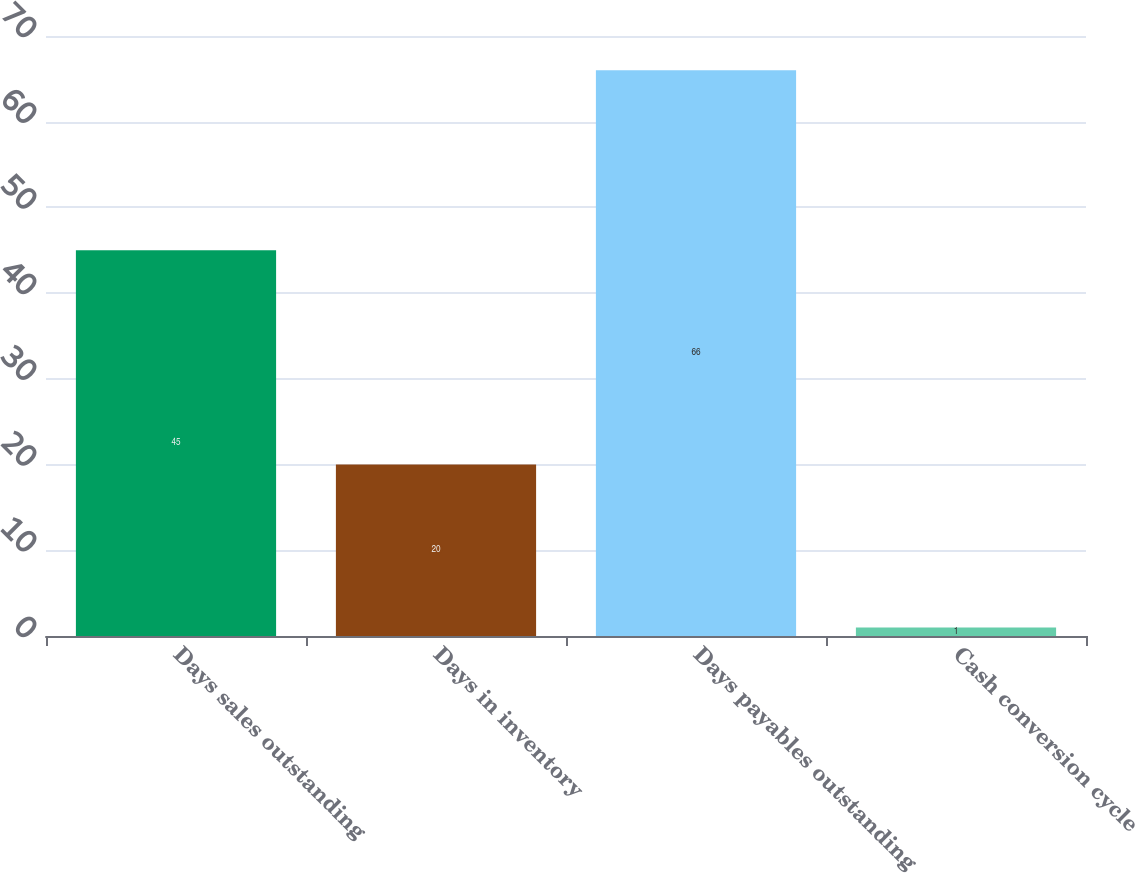<chart> <loc_0><loc_0><loc_500><loc_500><bar_chart><fcel>Days sales outstanding<fcel>Days in inventory<fcel>Days payables outstanding<fcel>Cash conversion cycle<nl><fcel>45<fcel>20<fcel>66<fcel>1<nl></chart> 